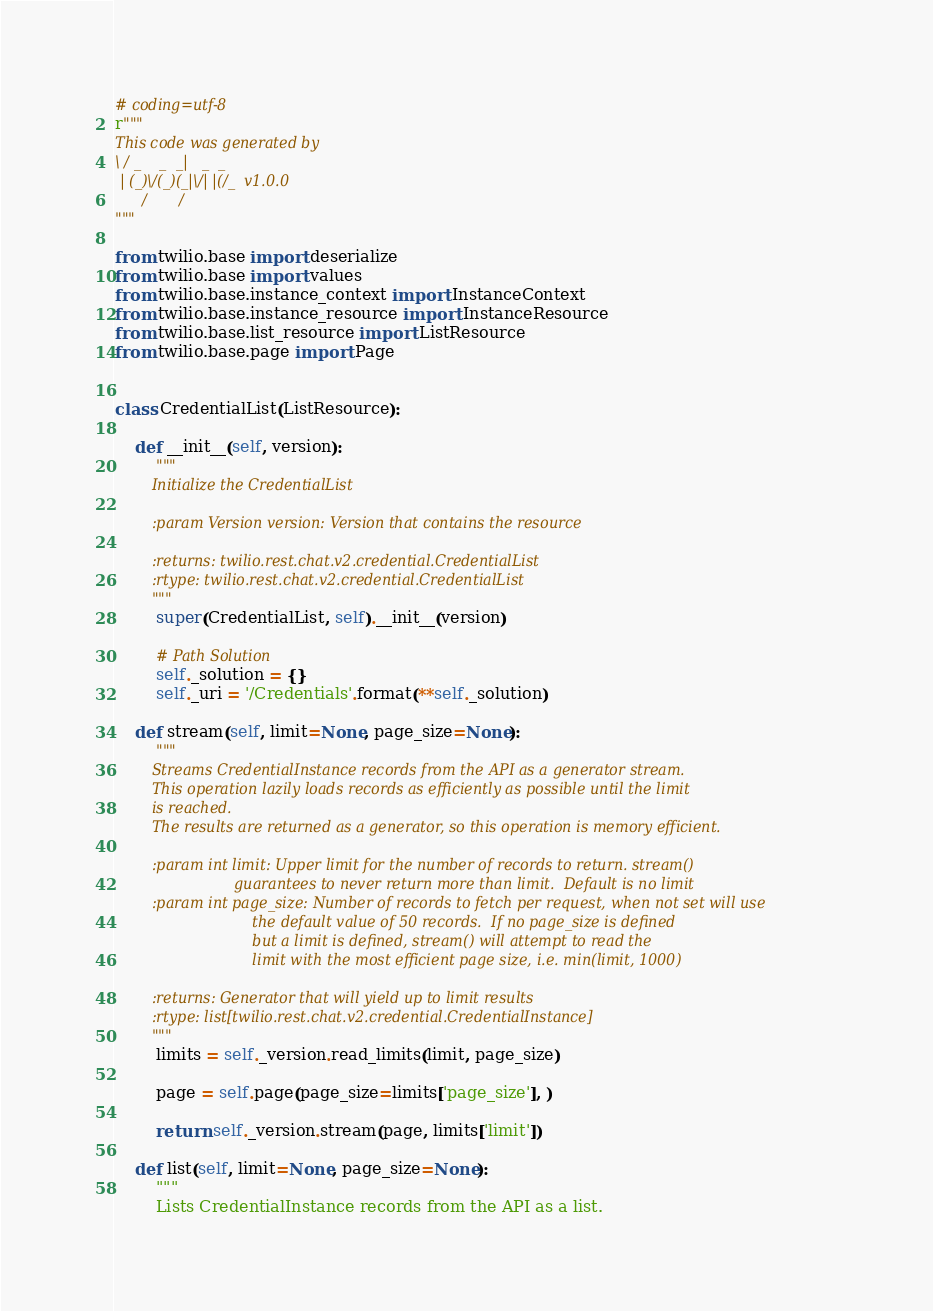Convert code to text. <code><loc_0><loc_0><loc_500><loc_500><_Python_># coding=utf-8
r"""
This code was generated by
\ / _    _  _|   _  _
 | (_)\/(_)(_|\/| |(/_  v1.0.0
      /       /
"""

from twilio.base import deserialize
from twilio.base import values
from twilio.base.instance_context import InstanceContext
from twilio.base.instance_resource import InstanceResource
from twilio.base.list_resource import ListResource
from twilio.base.page import Page


class CredentialList(ListResource):

    def __init__(self, version):
        """
        Initialize the CredentialList

        :param Version version: Version that contains the resource

        :returns: twilio.rest.chat.v2.credential.CredentialList
        :rtype: twilio.rest.chat.v2.credential.CredentialList
        """
        super(CredentialList, self).__init__(version)

        # Path Solution
        self._solution = {}
        self._uri = '/Credentials'.format(**self._solution)

    def stream(self, limit=None, page_size=None):
        """
        Streams CredentialInstance records from the API as a generator stream.
        This operation lazily loads records as efficiently as possible until the limit
        is reached.
        The results are returned as a generator, so this operation is memory efficient.

        :param int limit: Upper limit for the number of records to return. stream()
                          guarantees to never return more than limit.  Default is no limit
        :param int page_size: Number of records to fetch per request, when not set will use
                              the default value of 50 records.  If no page_size is defined
                              but a limit is defined, stream() will attempt to read the
                              limit with the most efficient page size, i.e. min(limit, 1000)

        :returns: Generator that will yield up to limit results
        :rtype: list[twilio.rest.chat.v2.credential.CredentialInstance]
        """
        limits = self._version.read_limits(limit, page_size)

        page = self.page(page_size=limits['page_size'], )

        return self._version.stream(page, limits['limit'])

    def list(self, limit=None, page_size=None):
        """
        Lists CredentialInstance records from the API as a list.</code> 